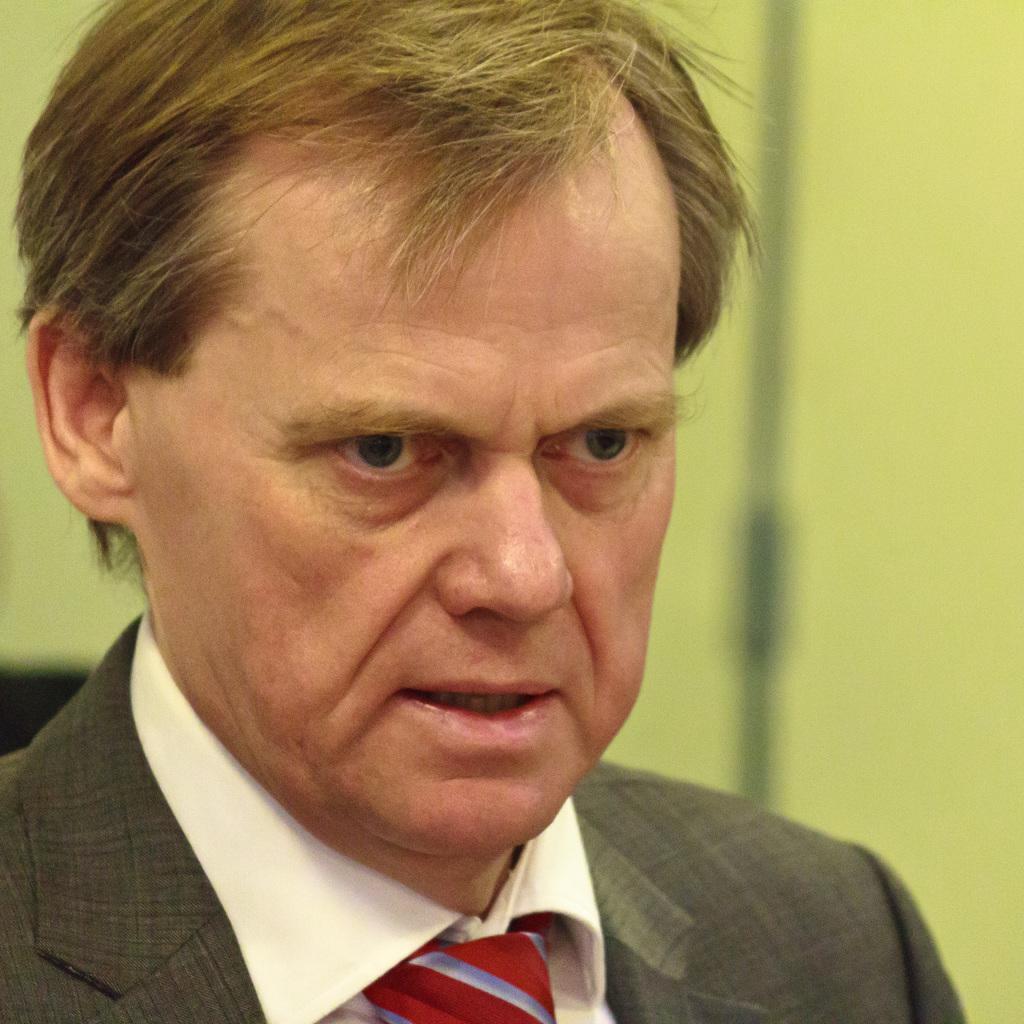Describe this image in one or two sentences. In this image I can see a person wearing grey color blazer,white shirt and a red tie. Background is in green color. 